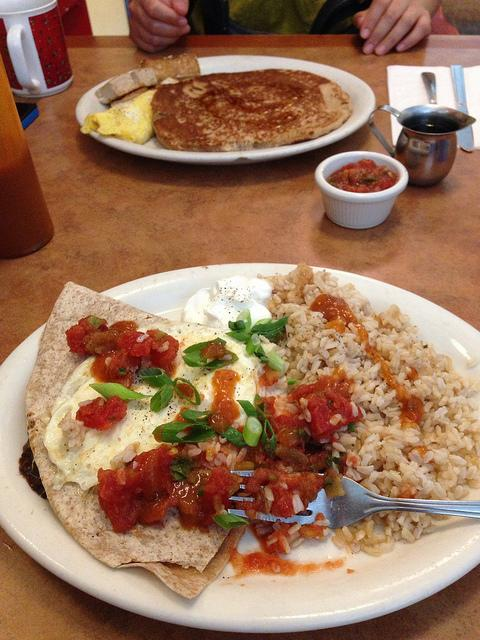What is the side dish on the plate in the foreground? rice 